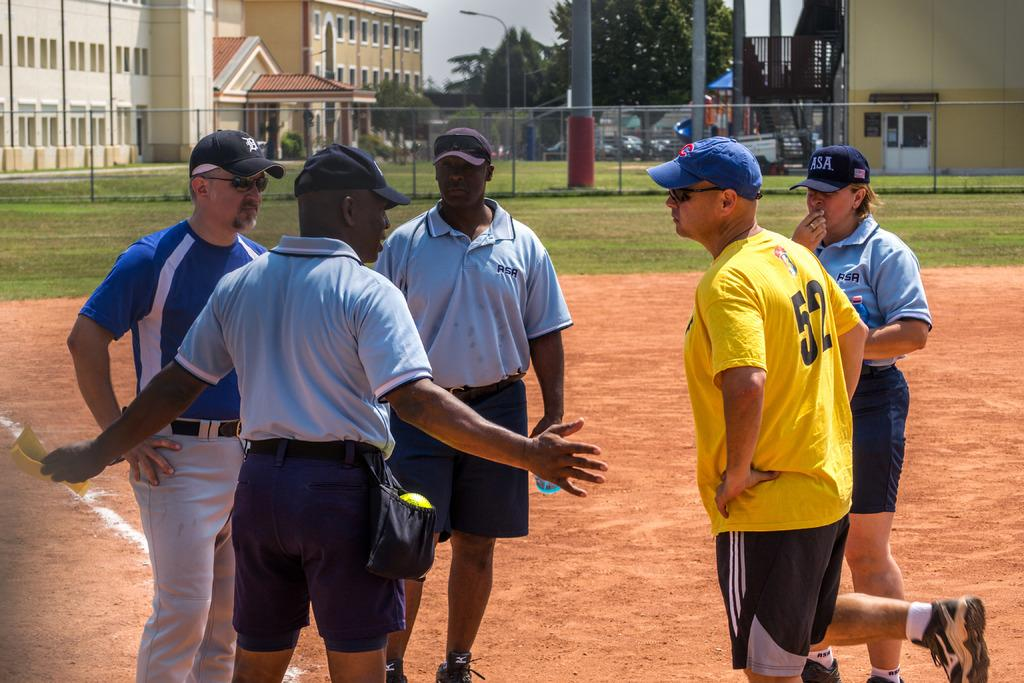<image>
Render a clear and concise summary of the photo. The man in yellow wears a number 52 top. 